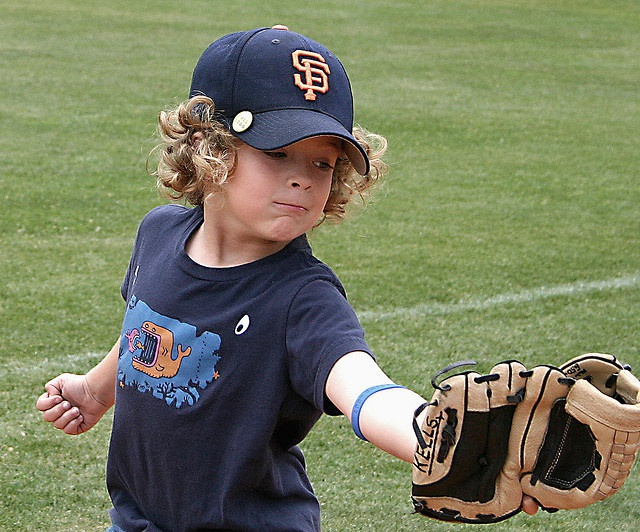Describe the objects in this image and their specific colors. I can see people in tan, black, gray, and brown tones and baseball glove in tan, black, and gray tones in this image. 